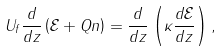Convert formula to latex. <formula><loc_0><loc_0><loc_500><loc_500>U _ { f } \frac { d } { d z } \left ( \mathcal { E } + Q n \right ) = \frac { d } { d z } \left ( \kappa \frac { d \mathcal { E } } { d z } \right ) ,</formula> 